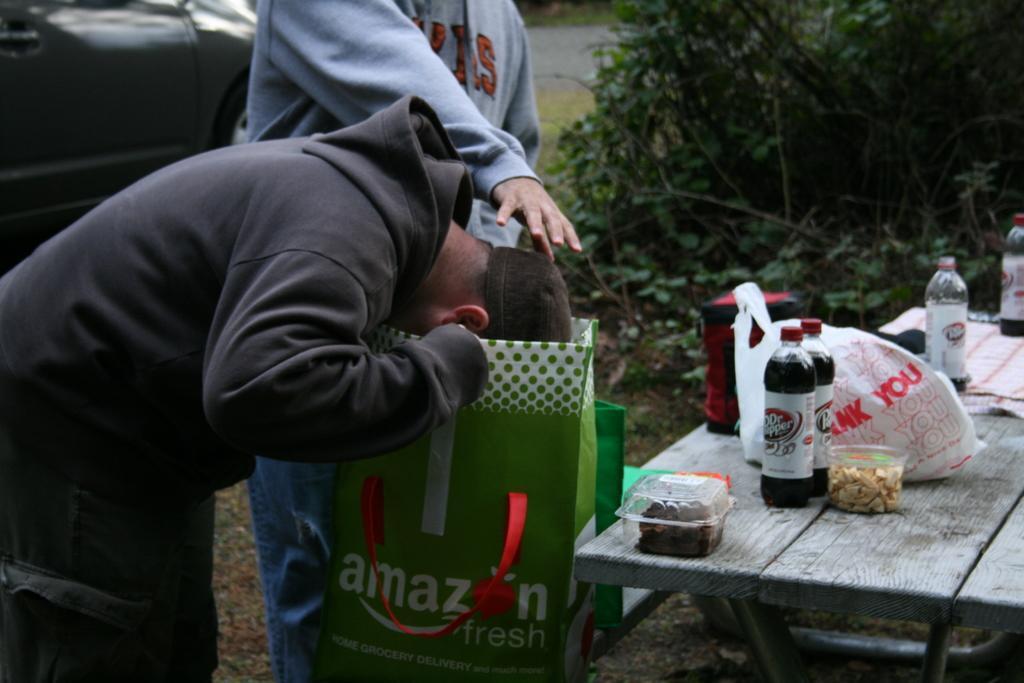How would you summarize this image in a sentence or two? there are two persons standing in front of a table on the table there are different items present near to them there was a vehicle. 